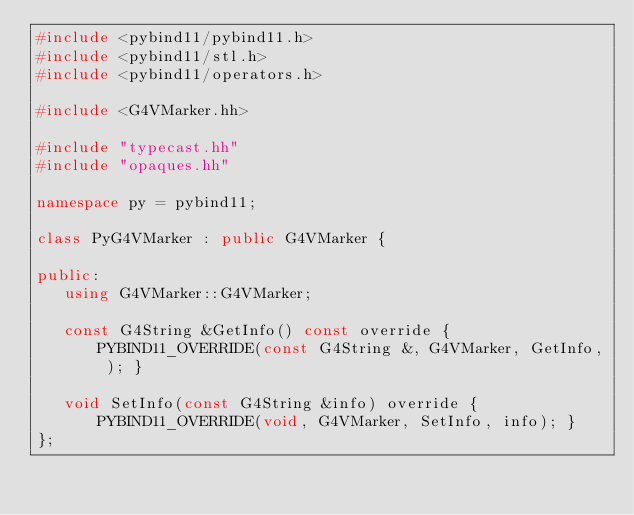Convert code to text. <code><loc_0><loc_0><loc_500><loc_500><_C++_>#include <pybind11/pybind11.h>
#include <pybind11/stl.h>
#include <pybind11/operators.h>

#include <G4VMarker.hh>

#include "typecast.hh"
#include "opaques.hh"

namespace py = pybind11;

class PyG4VMarker : public G4VMarker {

public:
   using G4VMarker::G4VMarker;

   const G4String &GetInfo() const override { PYBIND11_OVERRIDE(const G4String &, G4VMarker, GetInfo, ); }

   void SetInfo(const G4String &info) override { PYBIND11_OVERRIDE(void, G4VMarker, SetInfo, info); }
};
</code> 